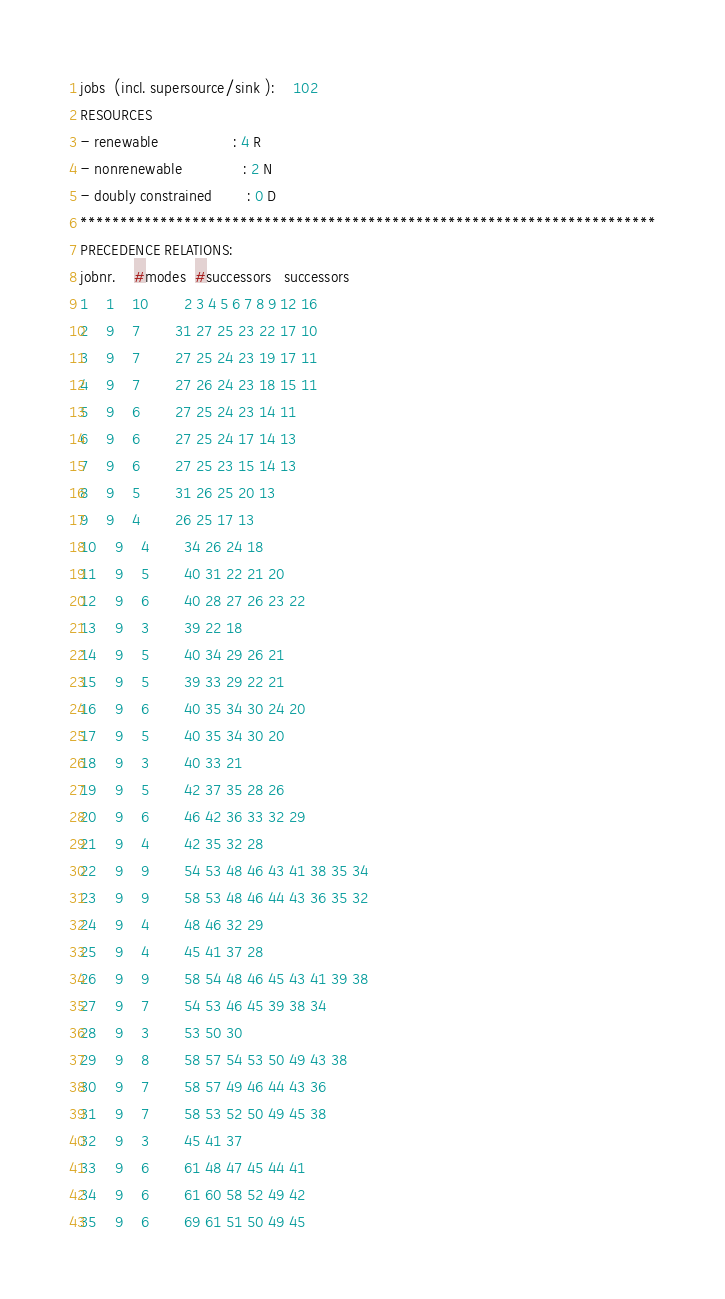<code> <loc_0><loc_0><loc_500><loc_500><_ObjectiveC_>jobs  (incl. supersource/sink ):	102
RESOURCES
- renewable                 : 4 R
- nonrenewable              : 2 N
- doubly constrained        : 0 D
************************************************************************
PRECEDENCE RELATIONS:
jobnr.    #modes  #successors   successors
1	1	10		2 3 4 5 6 7 8 9 12 16 
2	9	7		31 27 25 23 22 17 10 
3	9	7		27 25 24 23 19 17 11 
4	9	7		27 26 24 23 18 15 11 
5	9	6		27 25 24 23 14 11 
6	9	6		27 25 24 17 14 13 
7	9	6		27 25 23 15 14 13 
8	9	5		31 26 25 20 13 
9	9	4		26 25 17 13 
10	9	4		34 26 24 18 
11	9	5		40 31 22 21 20 
12	9	6		40 28 27 26 23 22 
13	9	3		39 22 18 
14	9	5		40 34 29 26 21 
15	9	5		39 33 29 22 21 
16	9	6		40 35 34 30 24 20 
17	9	5		40 35 34 30 20 
18	9	3		40 33 21 
19	9	5		42 37 35 28 26 
20	9	6		46 42 36 33 32 29 
21	9	4		42 35 32 28 
22	9	9		54 53 48 46 43 41 38 35 34 
23	9	9		58 53 48 46 44 43 36 35 32 
24	9	4		48 46 32 29 
25	9	4		45 41 37 28 
26	9	9		58 54 48 46 45 43 41 39 38 
27	9	7		54 53 46 45 39 38 34 
28	9	3		53 50 30 
29	9	8		58 57 54 53 50 49 43 38 
30	9	7		58 57 49 46 44 43 36 
31	9	7		58 53 52 50 49 45 38 
32	9	3		45 41 37 
33	9	6		61 48 47 45 44 41 
34	9	6		61 60 58 52 49 42 
35	9	6		69 61 51 50 49 45 </code> 